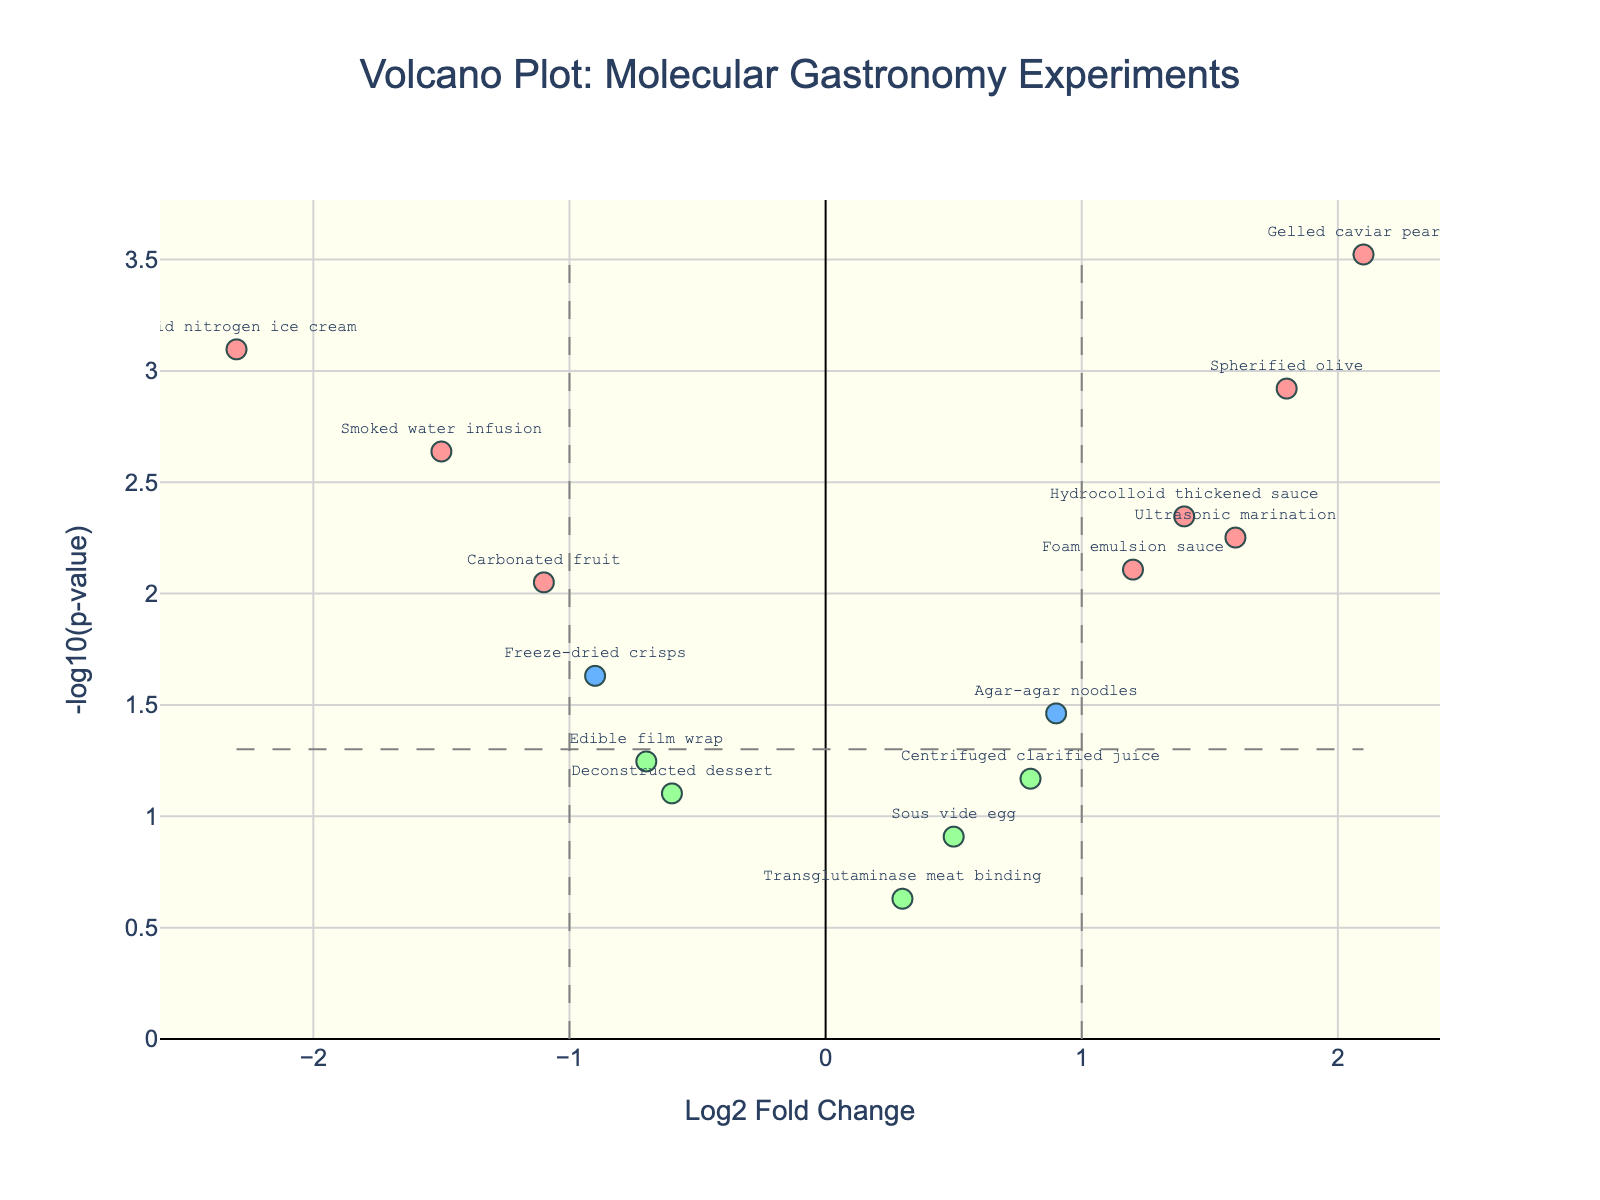What's the title of the plot? The title of the plot is displayed at the top center of the figure, indicating the subject of the plot.
Answer: Volcano Plot: Molecular Gastronomy Experiments What are the axes labels in the plot? The axes labels are typically shown along the sides of the plot. The x-axis label is "Log2 Fold Change" and the y-axis label is "-log10(p-value)".
Answer: Log2 Fold Change; -log10(p-value) How many ingredients have a Log2 Fold Change greater than 1 and are statistically significant? To determine this, identify the points with a Log2 Fold Change greater than 1 (look to the right of the vertical threshold line at x=1) and a -log10(p-value) greater than -log10(0.05) (above the horizontal threshold line). Count these points.
Answer: Three: Spherified olive, Gelled caviar pearls, Ultrasonic marination Which ingredient has the lowest p-value? The ingredient with the lowest p-value will have the highest -log10(p-value) value, which is the highest point along the y-axis.
Answer: Gelled caviar pearls Which ingredient has the highest negative log2 fold change and is statistically significant? Look for the ingredient with the most negative Log2 Fold Change (leftmost) and with a high -log10(p-value) (above the significance threshold line).
Answer: Liquid nitrogen ice cream Are there any ingredients that are not statistically significant but have a Log2 Fold Change greater than 1? Check for points to the right of the vertical line at x=1 that are below the horizontal threshold line for -log10(p-value).
Answer: No, there are none What Log2 Fold Change divides the plot into two halves? The X-axis value where the plot is split equally between positive and negative changes. This would be Log2 Fold Change of 0.
Answer: 0 How many ingredients show a reduction in Log2 Fold Change but are statistically significant? Look at the points left of Log2 Fold Change = 0 and above the -log10(p-value) threshold line; count these points.
Answer: Three: Liquid nitrogen ice cream, Smoked water infusion, Carbonated fruit 